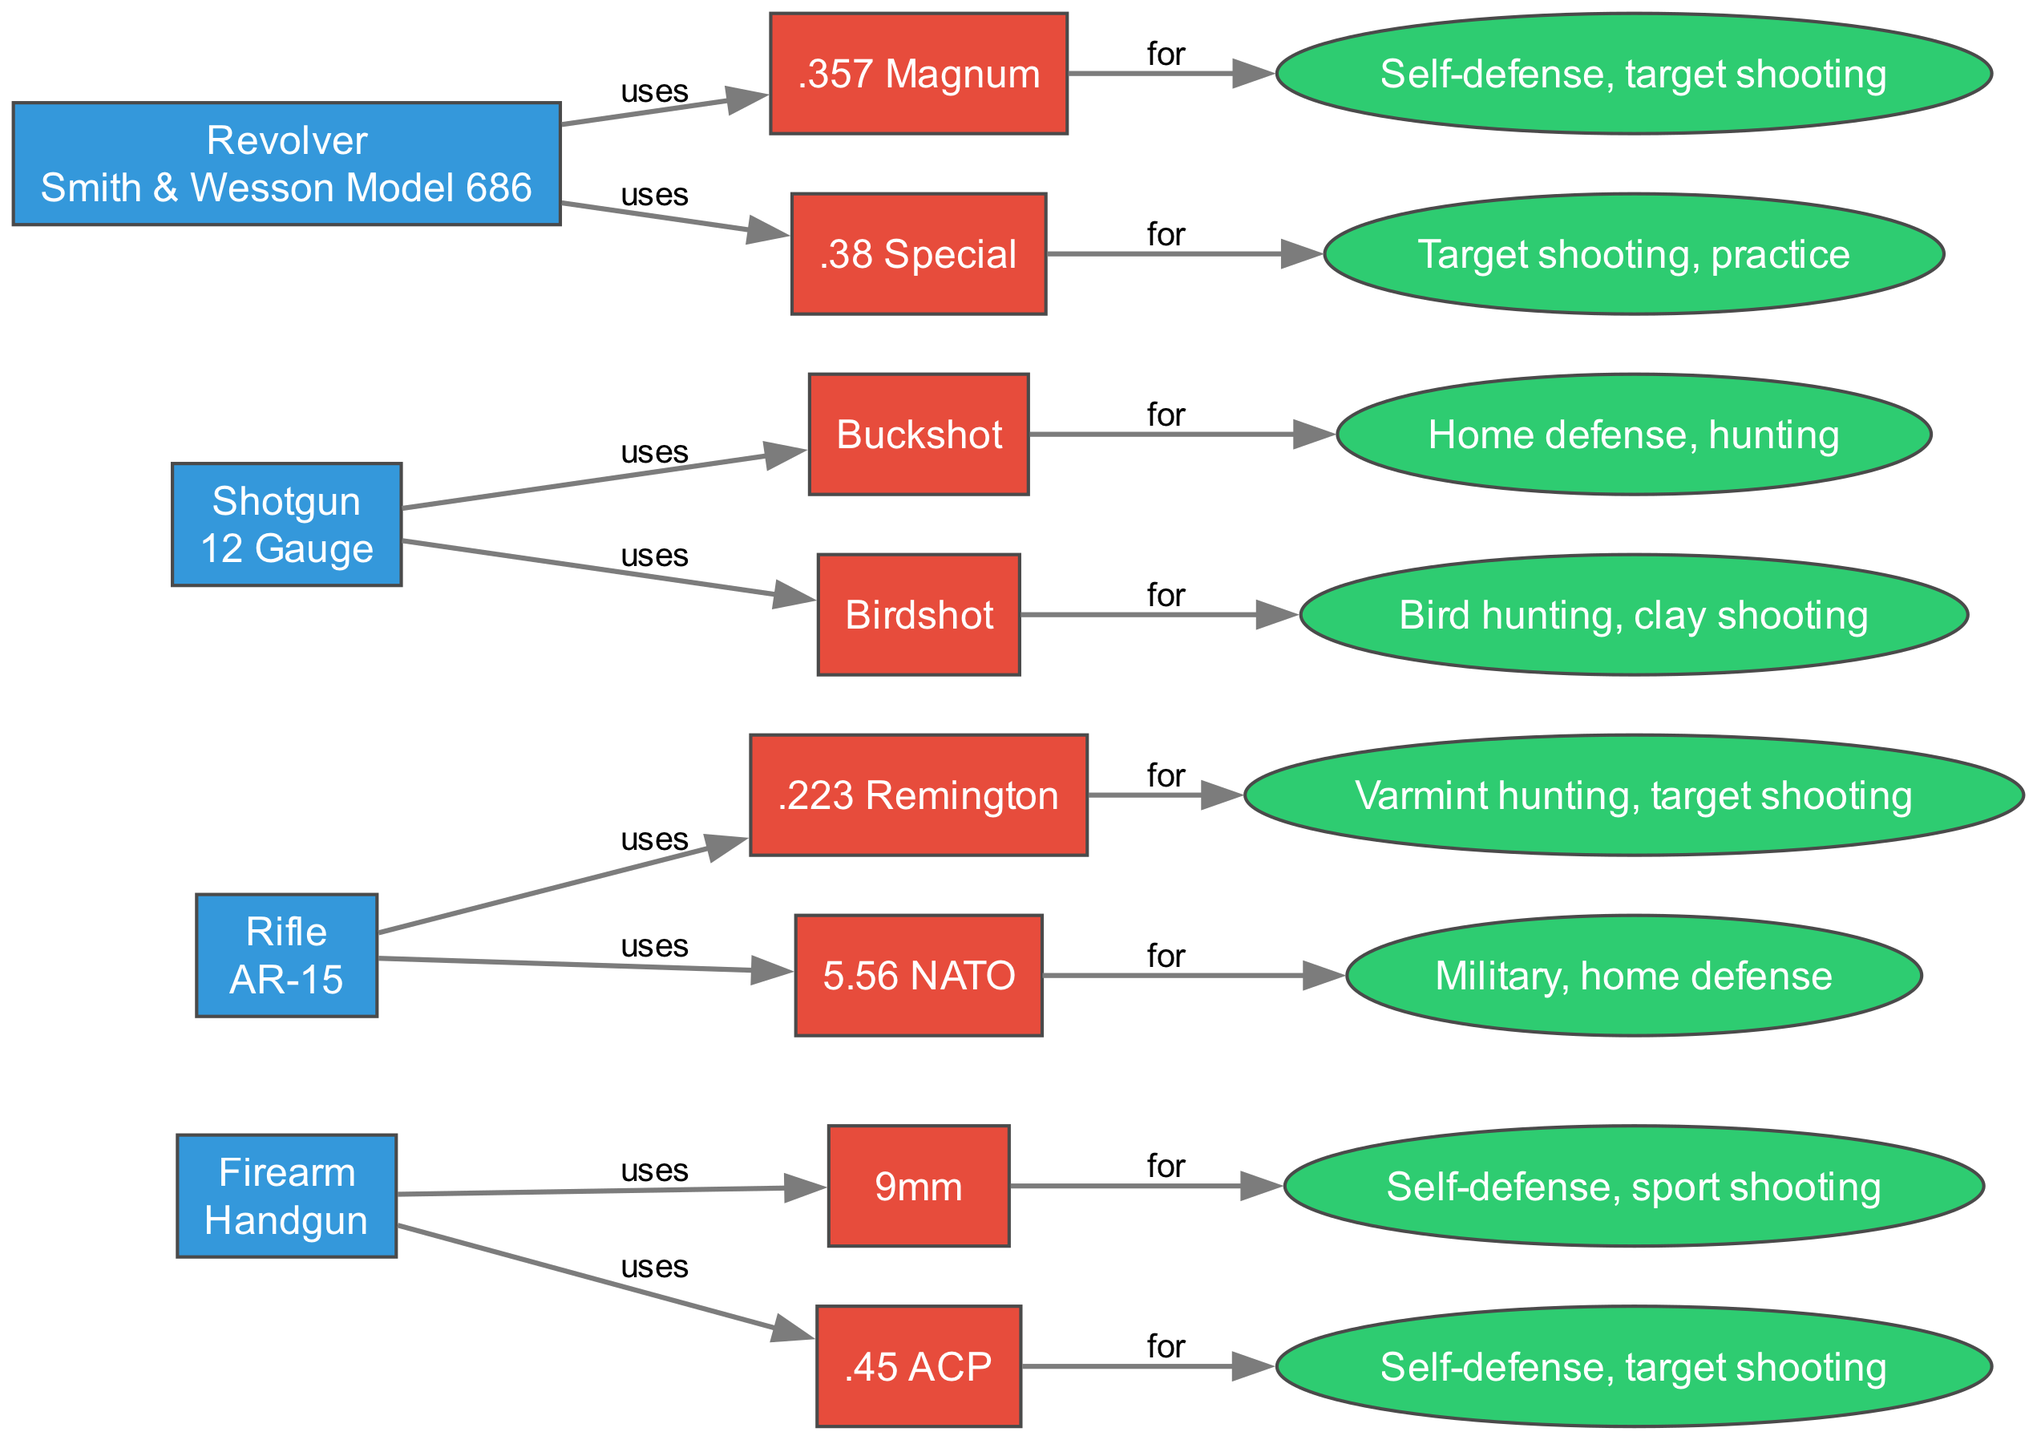What type of firearm is associated with 9mm ammunition? The diagram indicates that 9mm ammunition is linked to the handgun type firearm. By tracking the connection from the 9mm node towards its parent node, the firearm type can be identified as a handgun.
Answer: Handgun What is the primary use of .223 Remington ammunition? The .223 Remington node shows that its associated use is for varmint hunting and target shooting. This information can be found in the use node that connects to the .223 Remington ammunition node.
Answer: Varmint hunting, target shooting How many types of ammunition are listed for the 12 Gauge shotgun? The diagram includes two ammunition types for the 12 Gauge shotgun—buckshot and birdshot. Counting the connections from the 12 Gauge shotgun node to its ammunition nodes provides the total as two.
Answer: 2 Which ammunition is used for home defense? The diagram clearly states that the 5.56 NATO ammunition is used for military and home defense. By following the link from the 5.56 NATO node to its use node, we can identify home defense as one of its uses.
Answer: 5.56 NATO What is the relationship between the Smith & Wesson Model 686 and .38 Special? The .38 Special node connects to the Smith & Wesson Model 686 node, indicating that it is one of the types of ammunition used with that specific revolver. The direct connection signifies this relationship clearly.
Answer: .38 Special What color are the nodes representing ammunition in the flow chart? The diagram depicts ammunition nodes in a red color, as indicated by their assigned fillcolor property within the code. Recognizing the color assigned to ammunition nodes allows one to easily identify them within the diagram.
Answer: Red Which firearm type uses buckshot? Following the arrows from the buckshot node, we see it connects to the 12 Gauge shotgun, thereby confirming that the shotgun is the firearm type associated with this ammunition.
Answer: Shotgun How many nodes represent revolver ammunition in the diagram? The revolver has two ammunition types listed: .357 Magnum and .38 Special. Counting the nodes connected to the revolver node reveals a total of two ammunition nodes.
Answer: 2 